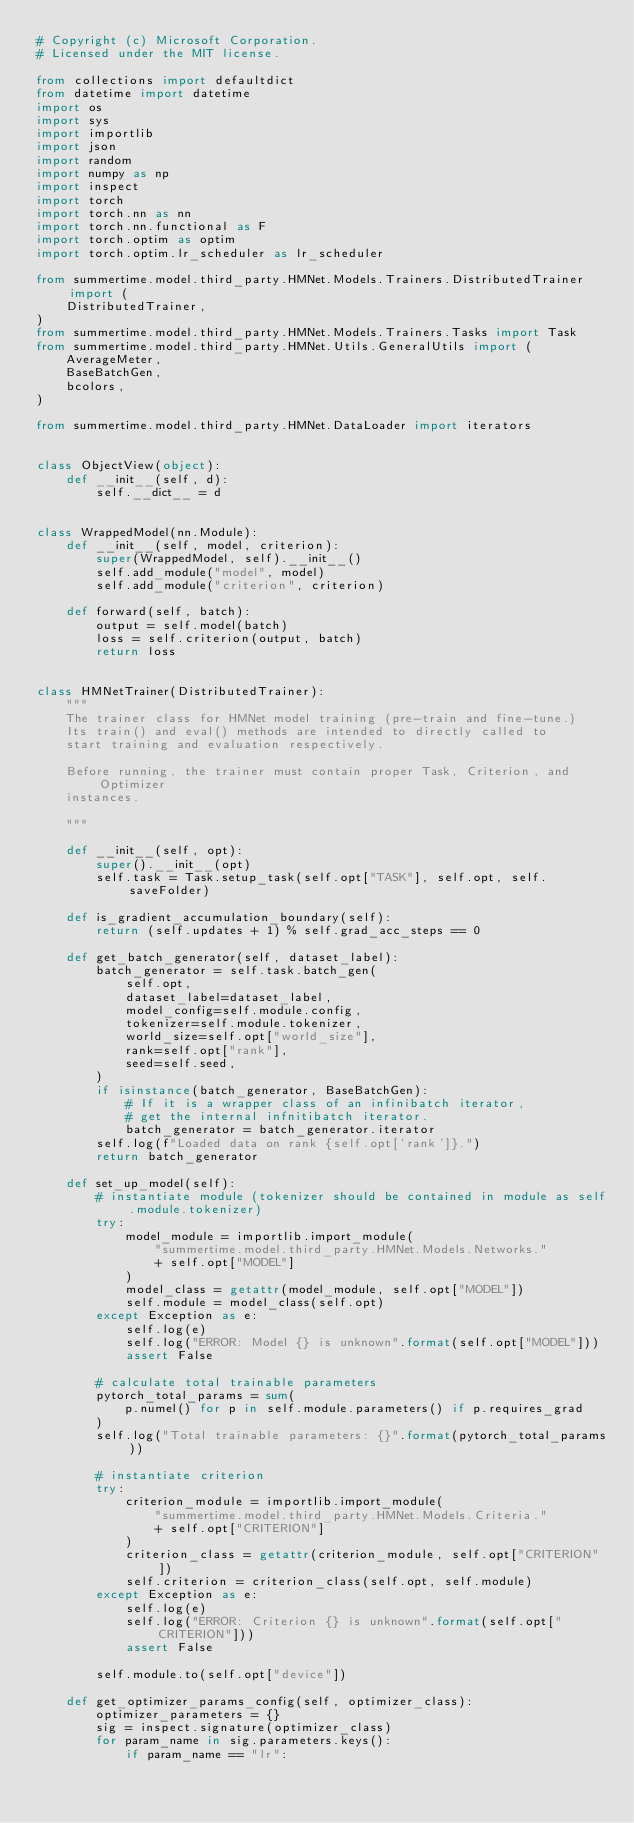<code> <loc_0><loc_0><loc_500><loc_500><_Python_># Copyright (c) Microsoft Corporation.
# Licensed under the MIT license.

from collections import defaultdict
from datetime import datetime
import os
import sys
import importlib
import json
import random
import numpy as np
import inspect
import torch
import torch.nn as nn
import torch.nn.functional as F
import torch.optim as optim
import torch.optim.lr_scheduler as lr_scheduler

from summertime.model.third_party.HMNet.Models.Trainers.DistributedTrainer import (
    DistributedTrainer,
)
from summertime.model.third_party.HMNet.Models.Trainers.Tasks import Task
from summertime.model.third_party.HMNet.Utils.GeneralUtils import (
    AverageMeter,
    BaseBatchGen,
    bcolors,
)

from summertime.model.third_party.HMNet.DataLoader import iterators


class ObjectView(object):
    def __init__(self, d):
        self.__dict__ = d


class WrappedModel(nn.Module):
    def __init__(self, model, criterion):
        super(WrappedModel, self).__init__()
        self.add_module("model", model)
        self.add_module("criterion", criterion)

    def forward(self, batch):
        output = self.model(batch)
        loss = self.criterion(output, batch)
        return loss


class HMNetTrainer(DistributedTrainer):
    """
    The trainer class for HMNet model training (pre-train and fine-tune.)
    Its train() and eval() methods are intended to directly called to
    start training and evaluation respectively.

    Before running, the trainer must contain proper Task, Criterion, and Optimizer
    instances.

    """

    def __init__(self, opt):
        super().__init__(opt)
        self.task = Task.setup_task(self.opt["TASK"], self.opt, self.saveFolder)

    def is_gradient_accumulation_boundary(self):
        return (self.updates + 1) % self.grad_acc_steps == 0

    def get_batch_generator(self, dataset_label):
        batch_generator = self.task.batch_gen(
            self.opt,
            dataset_label=dataset_label,
            model_config=self.module.config,
            tokenizer=self.module.tokenizer,
            world_size=self.opt["world_size"],
            rank=self.opt["rank"],
            seed=self.seed,
        )
        if isinstance(batch_generator, BaseBatchGen):
            # If it is a wrapper class of an infinibatch iterator,
            # get the internal infnitibatch iterator.
            batch_generator = batch_generator.iterator
        self.log(f"Loaded data on rank {self.opt['rank']}.")
        return batch_generator

    def set_up_model(self):
        # instantiate module (tokenizer should be contained in module as self.module.tokenizer)
        try:
            model_module = importlib.import_module(
                "summertime.model.third_party.HMNet.Models.Networks."
                + self.opt["MODEL"]
            )
            model_class = getattr(model_module, self.opt["MODEL"])
            self.module = model_class(self.opt)
        except Exception as e:
            self.log(e)
            self.log("ERROR: Model {} is unknown".format(self.opt["MODEL"]))
            assert False

        # calculate total trainable parameters
        pytorch_total_params = sum(
            p.numel() for p in self.module.parameters() if p.requires_grad
        )
        self.log("Total trainable parameters: {}".format(pytorch_total_params))

        # instantiate criterion
        try:
            criterion_module = importlib.import_module(
                "summertime.model.third_party.HMNet.Models.Criteria."
                + self.opt["CRITERION"]
            )
            criterion_class = getattr(criterion_module, self.opt["CRITERION"])
            self.criterion = criterion_class(self.opt, self.module)
        except Exception as e:
            self.log(e)
            self.log("ERROR: Criterion {} is unknown".format(self.opt["CRITERION"]))
            assert False

        self.module.to(self.opt["device"])

    def get_optimizer_params_config(self, optimizer_class):
        optimizer_parameters = {}
        sig = inspect.signature(optimizer_class)
        for param_name in sig.parameters.keys():
            if param_name == "lr":</code> 